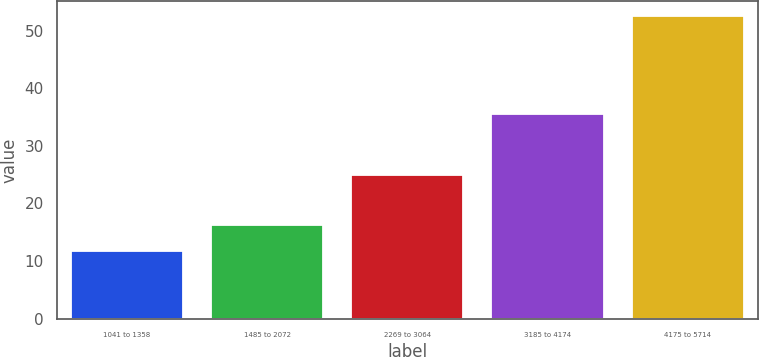Convert chart to OTSL. <chart><loc_0><loc_0><loc_500><loc_500><bar_chart><fcel>1041 to 1358<fcel>1485 to 2072<fcel>2269 to 3064<fcel>3185 to 4174<fcel>4175 to 5714<nl><fcel>11.73<fcel>16.17<fcel>24.86<fcel>35.52<fcel>52.46<nl></chart> 